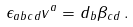Convert formula to latex. <formula><loc_0><loc_0><loc_500><loc_500>\epsilon _ { a b c d } v ^ { a } = d _ { b } \beta _ { c d } \, .</formula> 